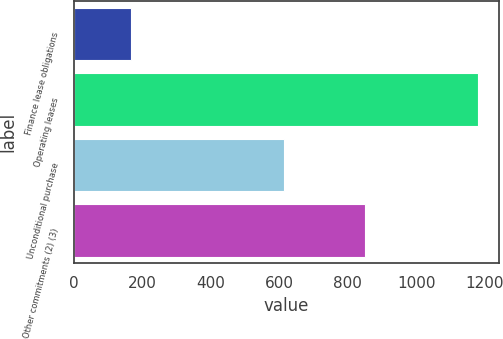Convert chart to OTSL. <chart><loc_0><loc_0><loc_500><loc_500><bar_chart><fcel>Finance lease obligations<fcel>Operating leases<fcel>Unconditional purchase<fcel>Other commitments (2) (3)<nl><fcel>166<fcel>1181<fcel>614<fcel>851<nl></chart> 